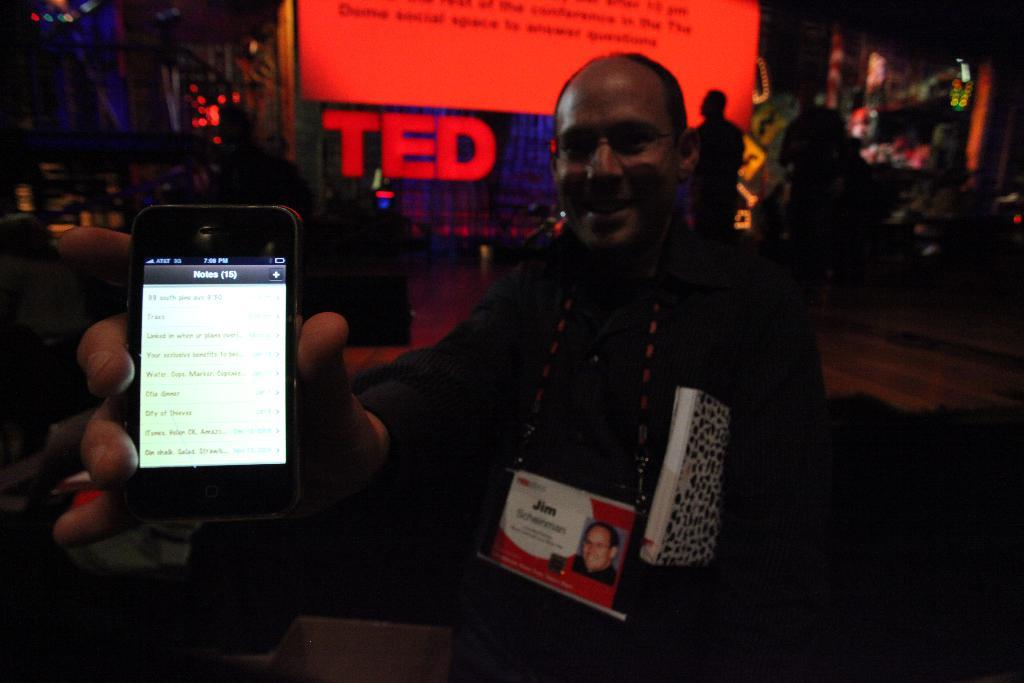<image>
Relay a brief, clear account of the picture shown. a man holding a phone at a TED talk 